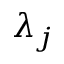Convert formula to latex. <formula><loc_0><loc_0><loc_500><loc_500>\lambda _ { j }</formula> 